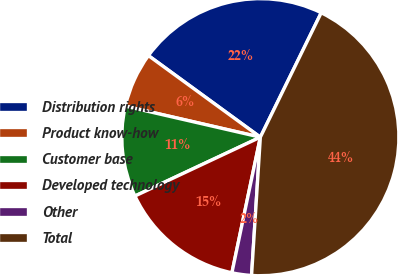Convert chart. <chart><loc_0><loc_0><loc_500><loc_500><pie_chart><fcel>Distribution rights<fcel>Product know-how<fcel>Customer base<fcel>Developed technology<fcel>Other<fcel>Total<nl><fcel>22.22%<fcel>6.43%<fcel>10.58%<fcel>14.73%<fcel>2.28%<fcel>43.78%<nl></chart> 